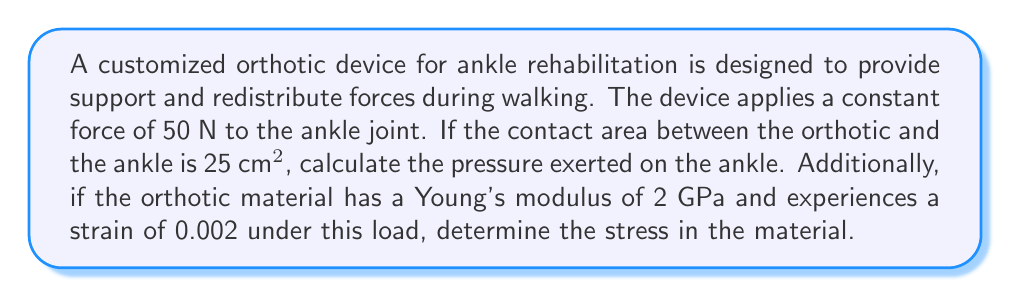What is the answer to this math problem? 1. Calculate the pressure on the ankle:
   Pressure is defined as force per unit area.
   $$P = \frac{F}{A}$$
   Where:
   $P$ = Pressure
   $F$ = Force (50 N)
   $A$ = Area (25 cm² = 0.0025 m²)

   $$P = \frac{50 \text{ N}}{0.0025 \text{ m}^2} = 20,000 \text{ Pa} = 20 \text{ kPa}$$

2. Calculate the stress in the orthotic material:
   Using Hooke's Law, we can relate stress to strain and Young's modulus:
   $$\sigma = E \cdot \varepsilon$$
   Where:
   $\sigma$ = Stress
   $E$ = Young's modulus (2 GPa = 2 × 10⁹ Pa)
   $\varepsilon$ = Strain (0.002)

   $$\sigma = (2 \times 10^9 \text{ Pa}) \cdot 0.002 = 4 \times 10^6 \text{ Pa} = 4 \text{ MPa}$$
Answer: Pressure on ankle: 20 kPa; Stress in orthotic: 4 MPa 